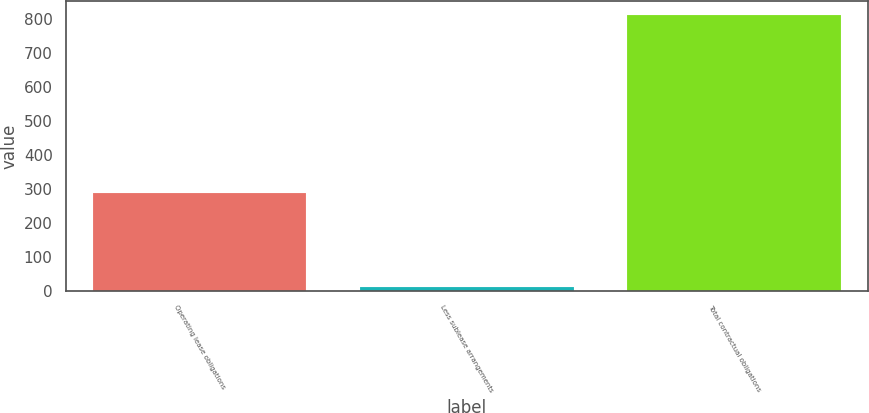<chart> <loc_0><loc_0><loc_500><loc_500><bar_chart><fcel>Operating lease obligations<fcel>Less sublease arrangements<fcel>Total contractual obligations<nl><fcel>287.6<fcel>11<fcel>812.4<nl></chart> 